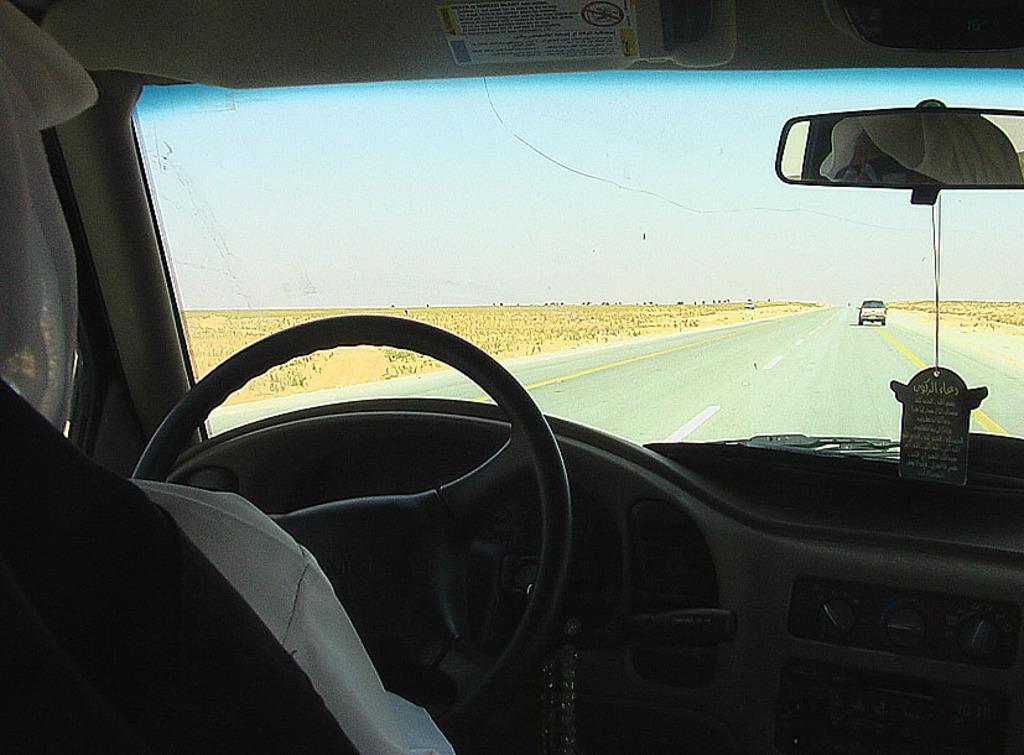How would you summarize this image in a sentence or two? In the picture I can see the inner view of a car In which a person is sitting on the seat and here we can see the steering, mirror, wind shield through which we can see a vehicle moving on the road, we can see the ground and the sky in the background. 